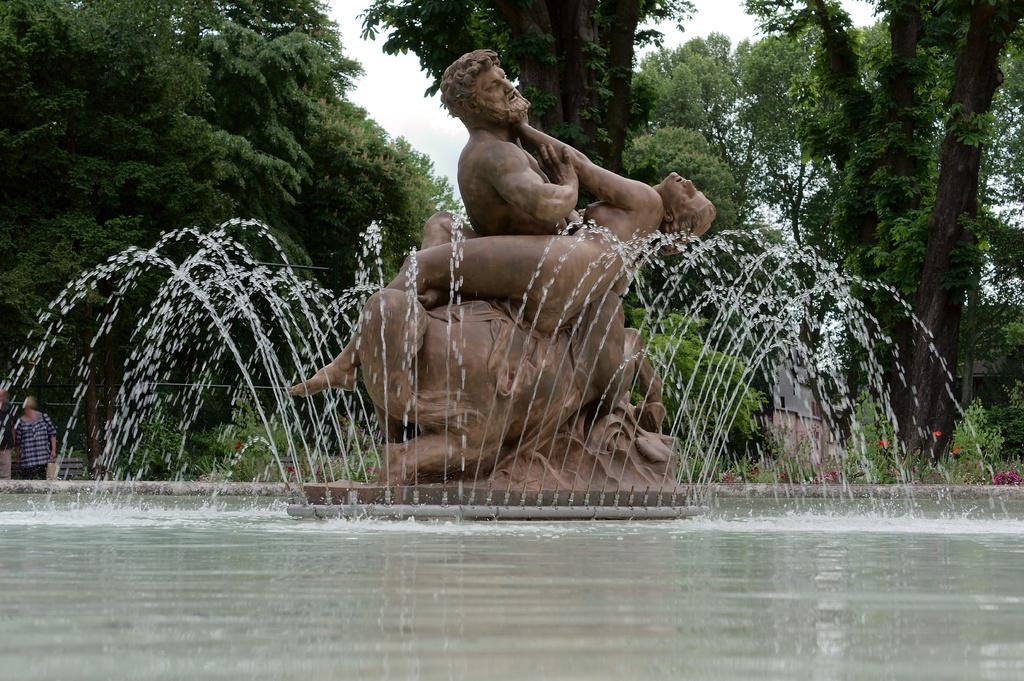In one or two sentences, can you explain what this image depicts? In this image, we can see a statue, water fountains. At the bottom, we can see water. Background we can see trees, plants, building and sky. Left side of the image, we can see few people are standing. 